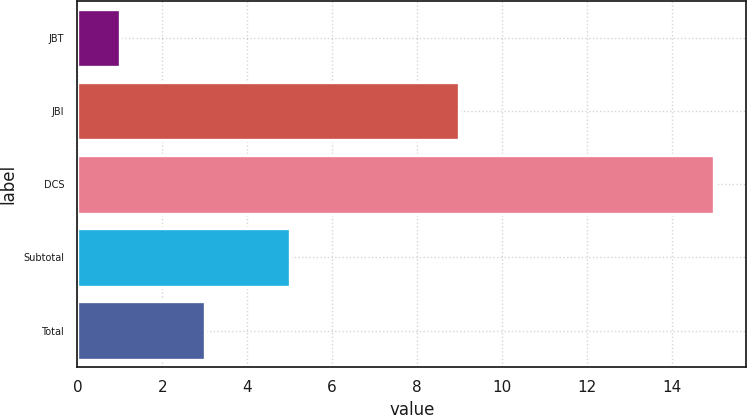Convert chart to OTSL. <chart><loc_0><loc_0><loc_500><loc_500><bar_chart><fcel>JBT<fcel>JBI<fcel>DCS<fcel>Subtotal<fcel>Total<nl><fcel>1<fcel>9<fcel>15<fcel>5<fcel>3<nl></chart> 